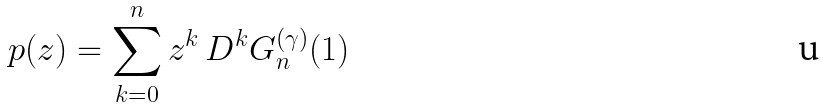<formula> <loc_0><loc_0><loc_500><loc_500>p ( z ) = \sum _ { k = 0 } ^ { n } z ^ { k } \, D ^ { k } G _ { n } ^ { ( \gamma ) } ( 1 )</formula> 